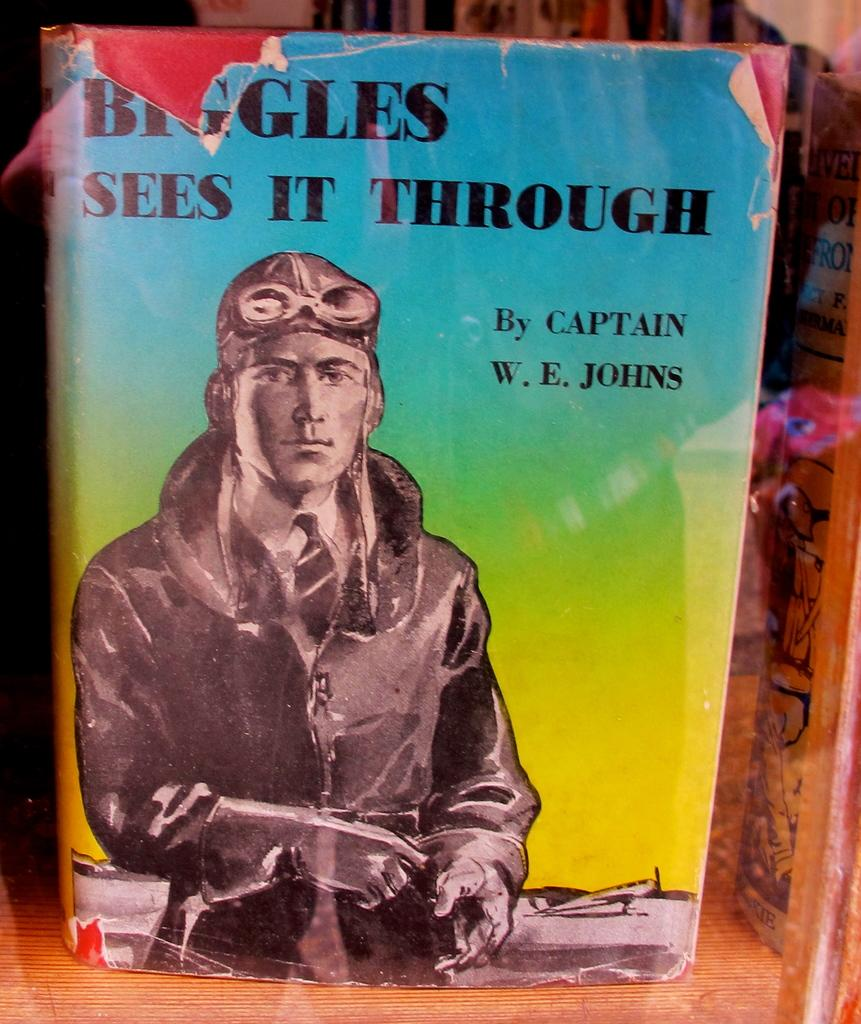<image>
Summarize the visual content of the image. A Captain WE Johns books has a ripped cover 